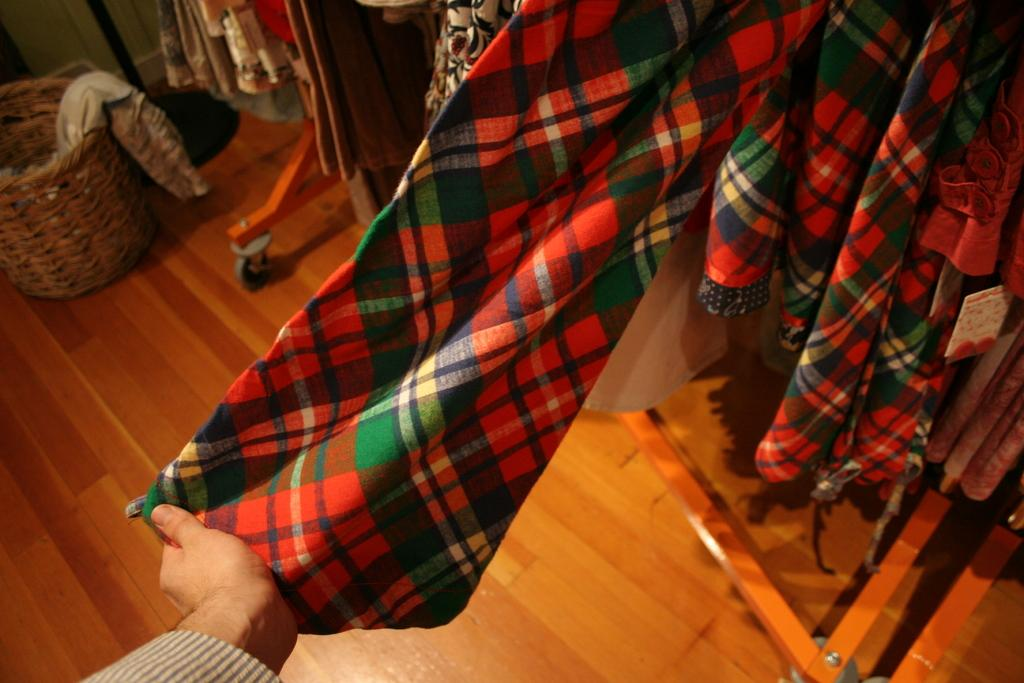What is the person holding in the image? The person is holding a multicolored dress. What can be seen hanging in the background? There are many clothes hanging in the background. What is located at the left side of the image? There is a wooden basket at the left side of the image. What is inside the wooden basket? The wooden basket contains clothes. What type of surface is present in the image? There is a wooden surface in the image. What type of sleet can be seen falling on the clothes in the image? There is no sleet present in the image; it is an indoor setting with no precipitation. How many buns are visible on the wooden surface in the image? There are no buns present in the image; it features clothes and a wooden basket. 